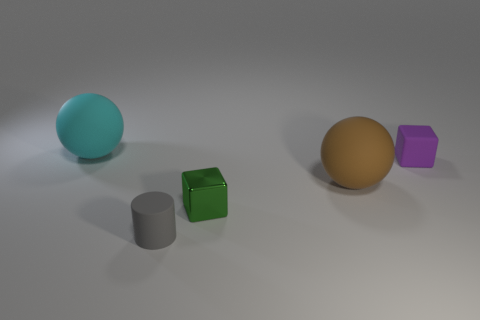Add 1 brown things. How many objects exist? 6 Subtract all blocks. How many objects are left? 3 Subtract 0 yellow cylinders. How many objects are left? 5 Subtract all small purple blocks. Subtract all large green cylinders. How many objects are left? 4 Add 4 small gray rubber cylinders. How many small gray rubber cylinders are left? 5 Add 2 brown matte objects. How many brown matte objects exist? 3 